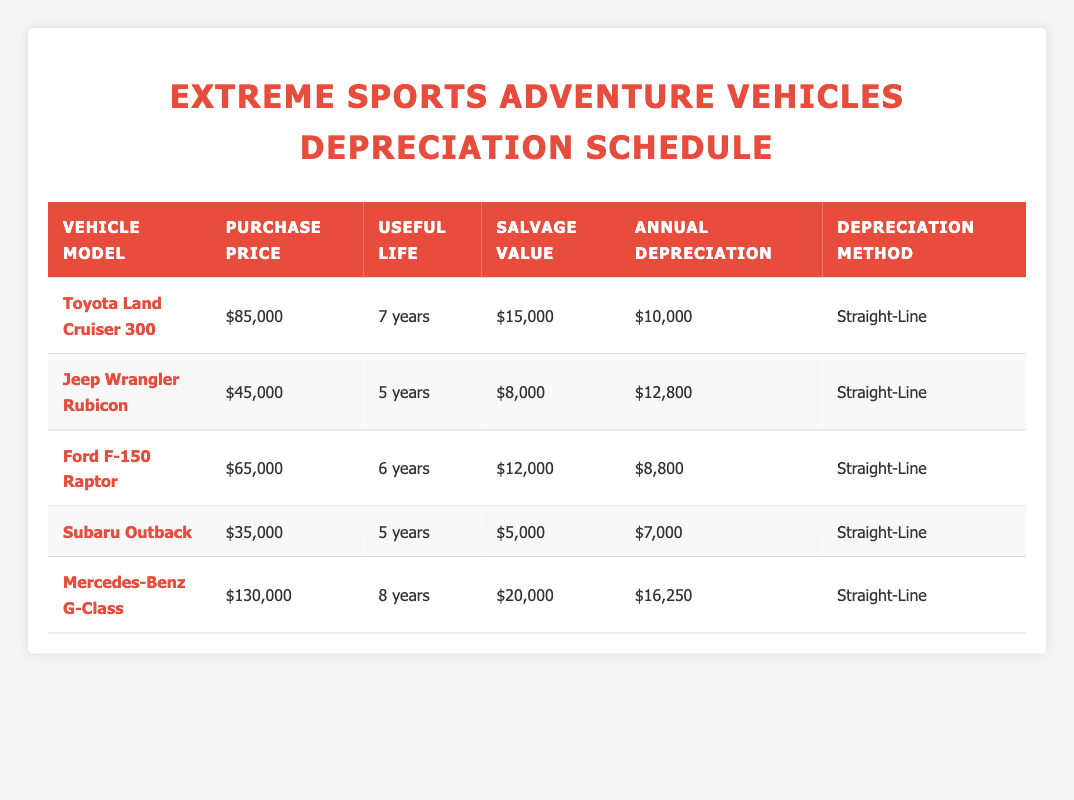What is the purchase price of the Ford F-150 Raptor? In the table, the column labeled "Purchase Price" shows the value for the Ford F-150 Raptor as 65,000.
Answer: 65,000 How long is the useful life of the Toyota Land Cruiser 300? The table displays the useful life of the Toyota Land Cruiser 300 in the "Useful Life" column, which indicates it as 7 years.
Answer: 7 years What is the total annual depreciation for all vehicles combined? To find the total annual depreciation, add up the annual depreciation values: 10,000 + 12,800 + 8,800 + 7,000 + 16,250 = 54,850.
Answer: 54,850 Is the salvage value of the Subaru Outback greater than 5,000? The table shows that the salvage value of the Subaru Outback is exactly 5,000, so it is not greater than that amount.
Answer: No What is the average annual depreciation for the vehicles in the table? The annual depreciation values are: 10,000, 12,800, 8,800, 7,000, and 16,250. Their sum is 54,850, and dividing this total by the number of vehicles (5) gives an average of 10,970.
Answer: 10,970 Which vehicle has the highest annual depreciation, and what is that amount? Comparing the annual depreciation figures, the Mercedes-Benz G-Class has the highest at 16,250.
Answer: Mercedes-Benz G-Class, 16,250 What is the difference in useful life between the Jeep Wrangler Rubicon and the Ford F-150 Raptor? The useful life of the Jeep Wrangler Rubicon is 5 years, and the Ford F-150 Raptor is 6 years. Thus, the difference is 6 - 5 = 1 year.
Answer: 1 year Are all vehicles depreciated using the straight-line method? The table lists the depreciation method for each vehicle, and they all indicate the straight-line method, confirming the answer.
Answer: Yes 